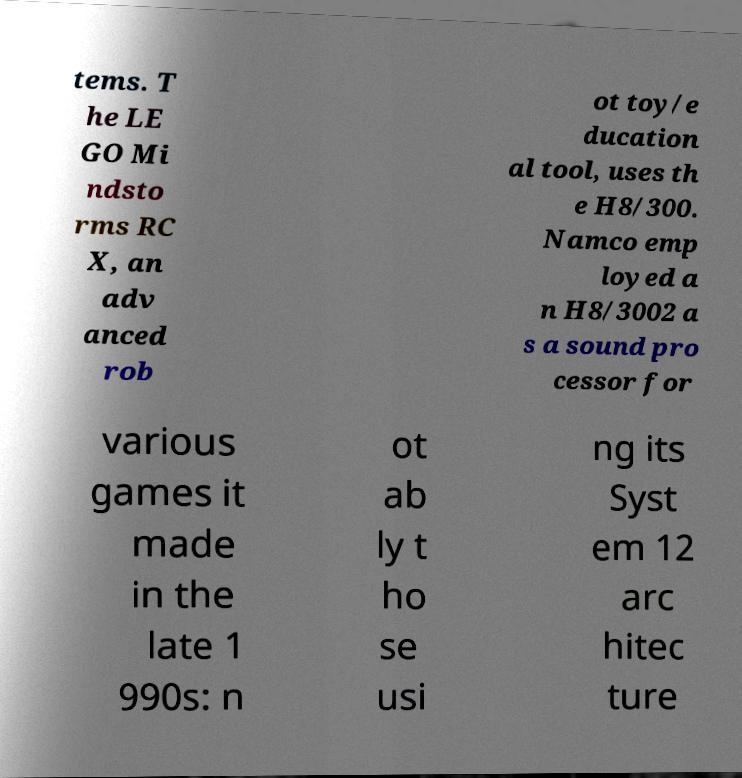Please read and relay the text visible in this image. What does it say? tems. T he LE GO Mi ndsto rms RC X, an adv anced rob ot toy/e ducation al tool, uses th e H8/300. Namco emp loyed a n H8/3002 a s a sound pro cessor for various games it made in the late 1 990s: n ot ab ly t ho se usi ng its Syst em 12 arc hitec ture 